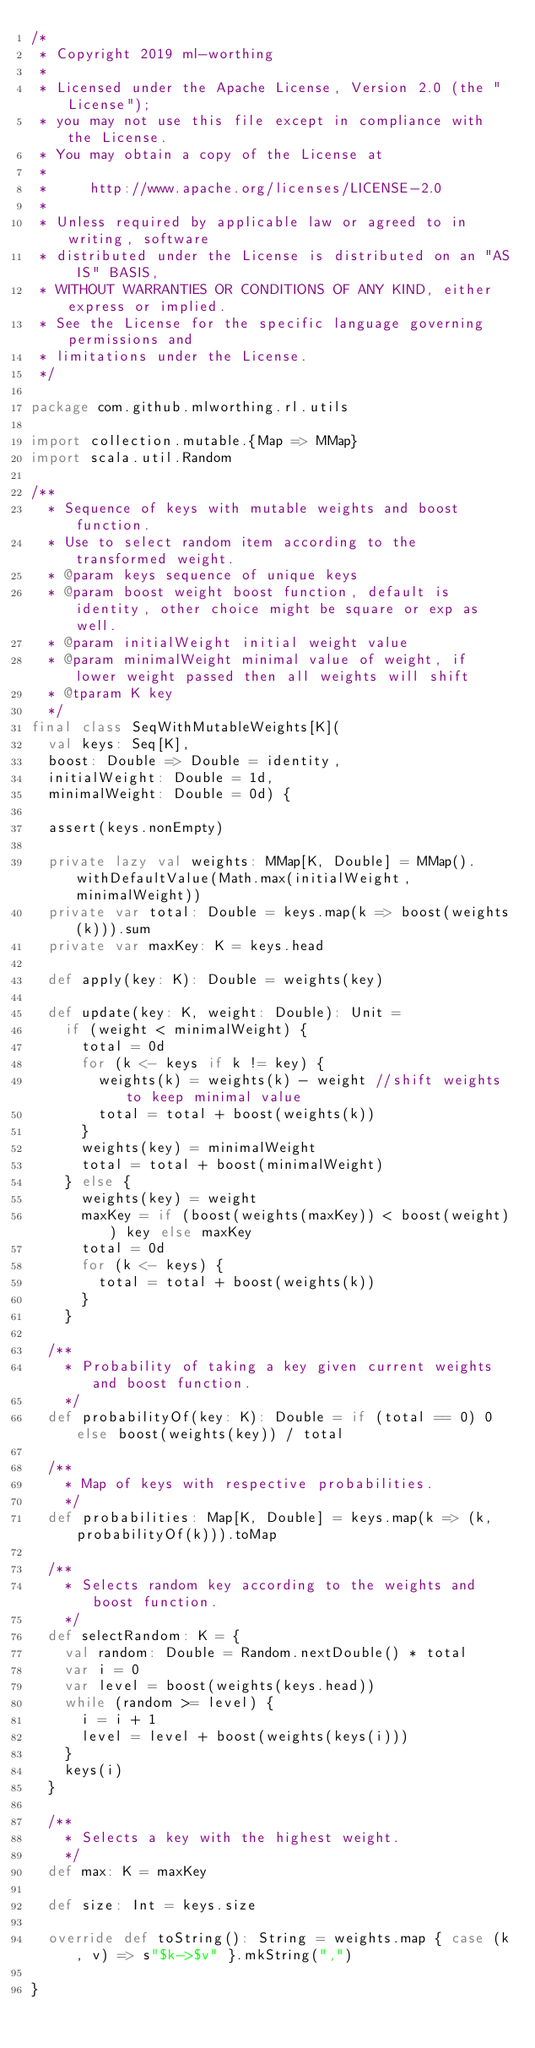<code> <loc_0><loc_0><loc_500><loc_500><_Scala_>/*
 * Copyright 2019 ml-worthing
 *
 * Licensed under the Apache License, Version 2.0 (the "License");
 * you may not use this file except in compliance with the License.
 * You may obtain a copy of the License at
 *
 *     http://www.apache.org/licenses/LICENSE-2.0
 *
 * Unless required by applicable law or agreed to in writing, software
 * distributed under the License is distributed on an "AS IS" BASIS,
 * WITHOUT WARRANTIES OR CONDITIONS OF ANY KIND, either express or implied.
 * See the License for the specific language governing permissions and
 * limitations under the License.
 */

package com.github.mlworthing.rl.utils

import collection.mutable.{Map => MMap}
import scala.util.Random

/**
  * Sequence of keys with mutable weights and boost function.
  * Use to select random item according to the transformed weight.
  * @param keys sequence of unique keys
  * @param boost weight boost function, default is identity, other choice might be square or exp as well.
  * @param initialWeight initial weight value
  * @param minimalWeight minimal value of weight, if lower weight passed then all weights will shift
  * @tparam K key
  */
final class SeqWithMutableWeights[K](
  val keys: Seq[K],
  boost: Double => Double = identity,
  initialWeight: Double = 1d,
  minimalWeight: Double = 0d) {

  assert(keys.nonEmpty)

  private lazy val weights: MMap[K, Double] = MMap().withDefaultValue(Math.max(initialWeight, minimalWeight))
  private var total: Double = keys.map(k => boost(weights(k))).sum
  private var maxKey: K = keys.head

  def apply(key: K): Double = weights(key)

  def update(key: K, weight: Double): Unit =
    if (weight < minimalWeight) {
      total = 0d
      for (k <- keys if k != key) {
        weights(k) = weights(k) - weight //shift weights to keep minimal value
        total = total + boost(weights(k))
      }
      weights(key) = minimalWeight
      total = total + boost(minimalWeight)
    } else {
      weights(key) = weight
      maxKey = if (boost(weights(maxKey)) < boost(weight)) key else maxKey
      total = 0d
      for (k <- keys) {
        total = total + boost(weights(k))
      }
    }

  /**
    * Probability of taking a key given current weights and boost function.
    */
  def probabilityOf(key: K): Double = if (total == 0) 0 else boost(weights(key)) / total

  /**
    * Map of keys with respective probabilities.
    */
  def probabilities: Map[K, Double] = keys.map(k => (k, probabilityOf(k))).toMap

  /**
    * Selects random key according to the weights and boost function.
    */
  def selectRandom: K = {
    val random: Double = Random.nextDouble() * total
    var i = 0
    var level = boost(weights(keys.head))
    while (random >= level) {
      i = i + 1
      level = level + boost(weights(keys(i)))
    }
    keys(i)
  }

  /**
    * Selects a key with the highest weight.
    */
  def max: K = maxKey

  def size: Int = keys.size

  override def toString(): String = weights.map { case (k, v) => s"$k->$v" }.mkString(",")

}
</code> 